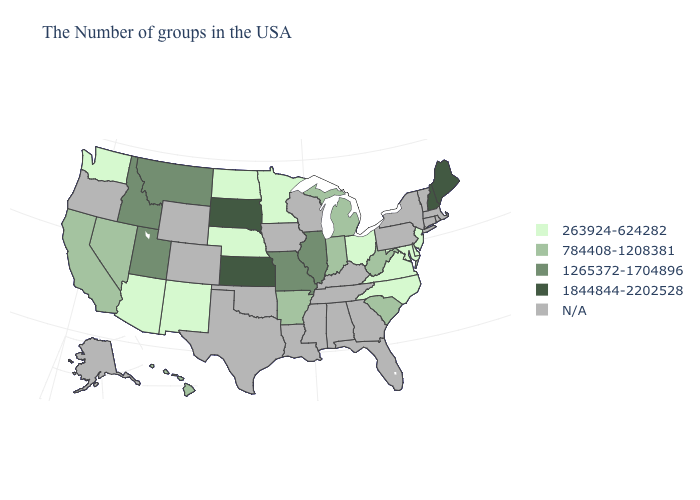What is the value of Louisiana?
Keep it brief. N/A. What is the value of Indiana?
Keep it brief. 784408-1208381. Name the states that have a value in the range 1265372-1704896?
Quick response, please. Illinois, Missouri, Utah, Montana, Idaho. Does Ohio have the lowest value in the USA?
Short answer required. Yes. Name the states that have a value in the range 263924-624282?
Write a very short answer. New Jersey, Delaware, Maryland, Virginia, North Carolina, Ohio, Minnesota, Nebraska, North Dakota, New Mexico, Arizona, Washington. What is the lowest value in the USA?
Quick response, please. 263924-624282. Name the states that have a value in the range 784408-1208381?
Answer briefly. South Carolina, West Virginia, Michigan, Indiana, Arkansas, Nevada, California, Hawaii. What is the value of Texas?
Short answer required. N/A. Among the states that border Missouri , which have the lowest value?
Quick response, please. Nebraska. Does New Mexico have the lowest value in the West?
Keep it brief. Yes. Which states have the lowest value in the Northeast?
Quick response, please. New Jersey. Name the states that have a value in the range 1265372-1704896?
Short answer required. Illinois, Missouri, Utah, Montana, Idaho. What is the lowest value in the West?
Concise answer only. 263924-624282. Name the states that have a value in the range 784408-1208381?
Short answer required. South Carolina, West Virginia, Michigan, Indiana, Arkansas, Nevada, California, Hawaii. 